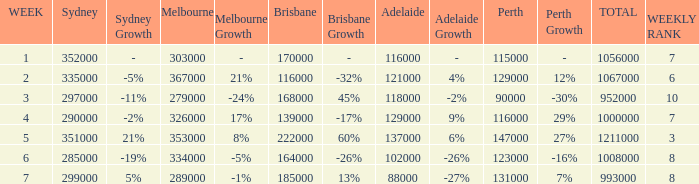How many episodes aired in Sydney in Week 3? 1.0. 